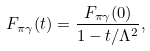<formula> <loc_0><loc_0><loc_500><loc_500>F _ { \pi \gamma } ( t ) = \frac { F _ { \pi \gamma } ( 0 ) } { 1 - t / \Lambda ^ { 2 } } ,</formula> 